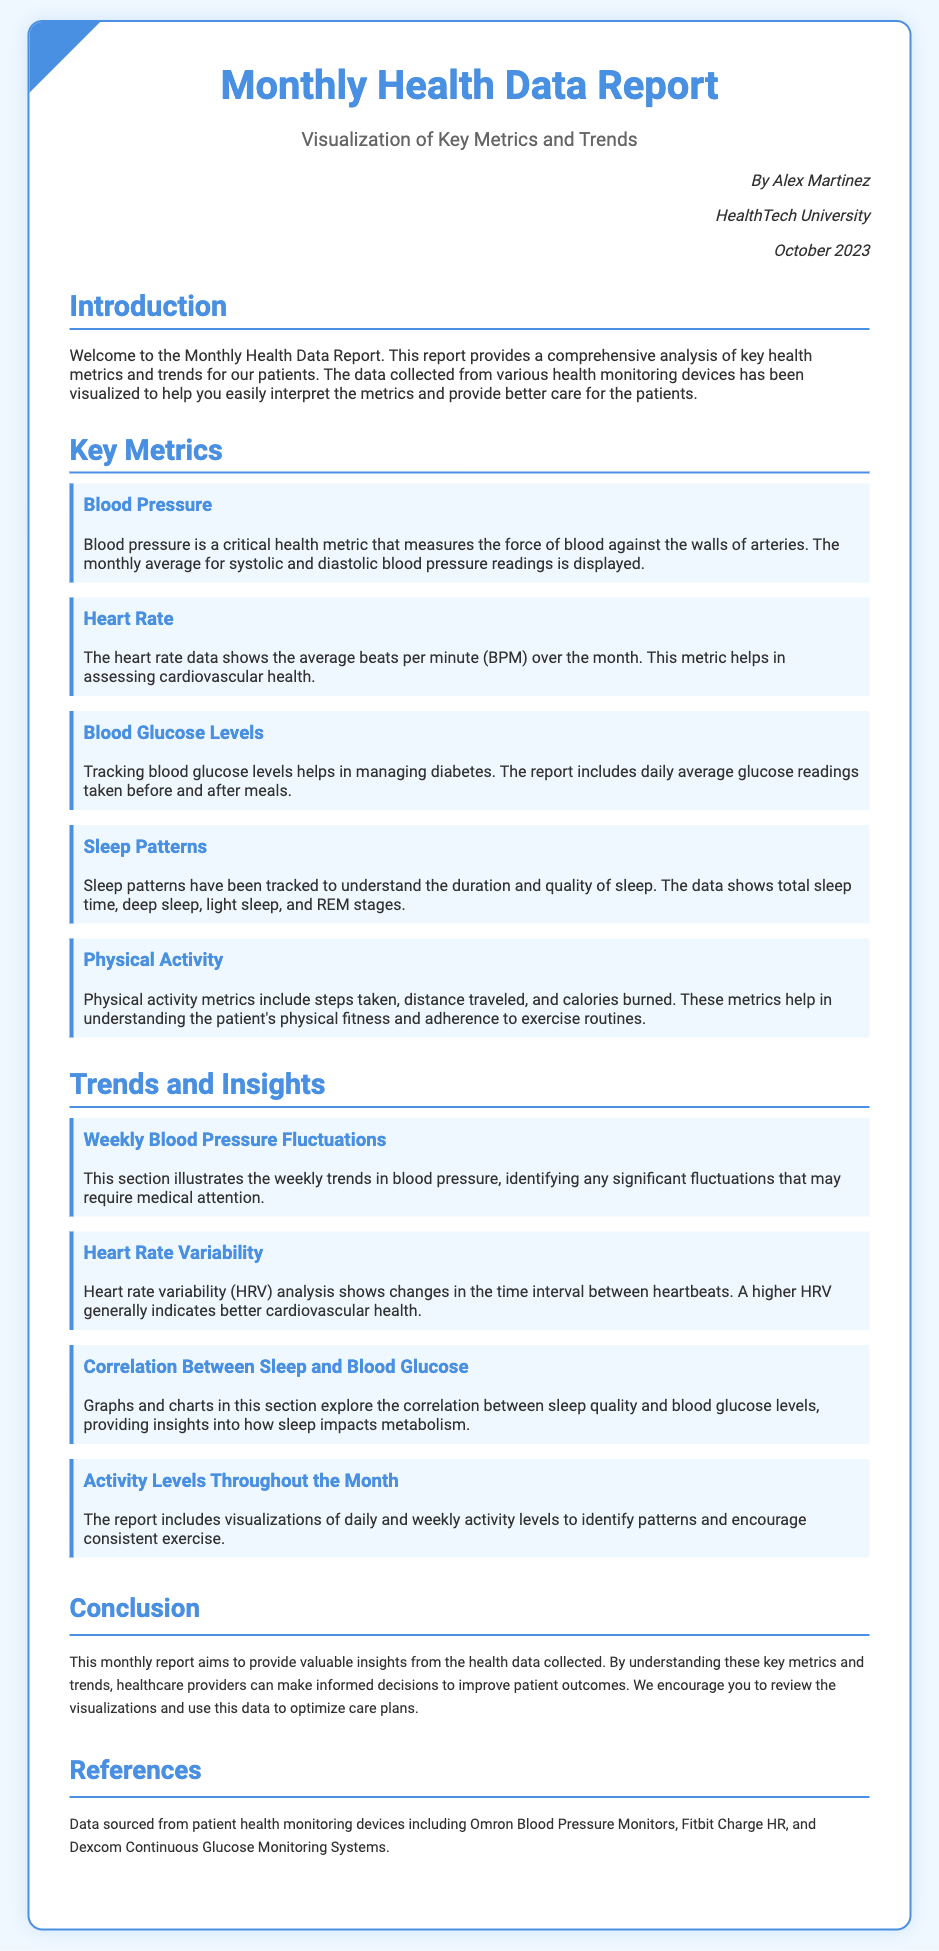what is the title of the report? The title is stated at the top of the document as the main heading.
Answer: Monthly Health Data Report who is the author of the report? The author is mentioned in the author info section of the document.
Answer: Alex Martinez what type of health data does the report analyze? The report specifies the type of health data being analyzed in the introduction.
Answer: Key health metrics and trends when was the report published? The publication date is provided in the author info section of the document.
Answer: October 2023 what metric assesses cardiovascular health? The report provides a specific health metric related to cardiovascular health under key metrics.
Answer: Heart Rate what does HRV stand for? The meaning of HRV is explained in the trends and insights section.
Answer: Heart Rate Variability which devices are referenced in the report? The references section lists the devices used for data collection.
Answer: Omron Blood Pressure Monitors, Fitbit Charge HR, and Dexcom Continuous Glucose Monitoring Systems how is sleep quality related to blood glucose levels? The document discusses this specific correlation in the trends and insights section.
Answer: Correlation Between Sleep and Blood Glucose 